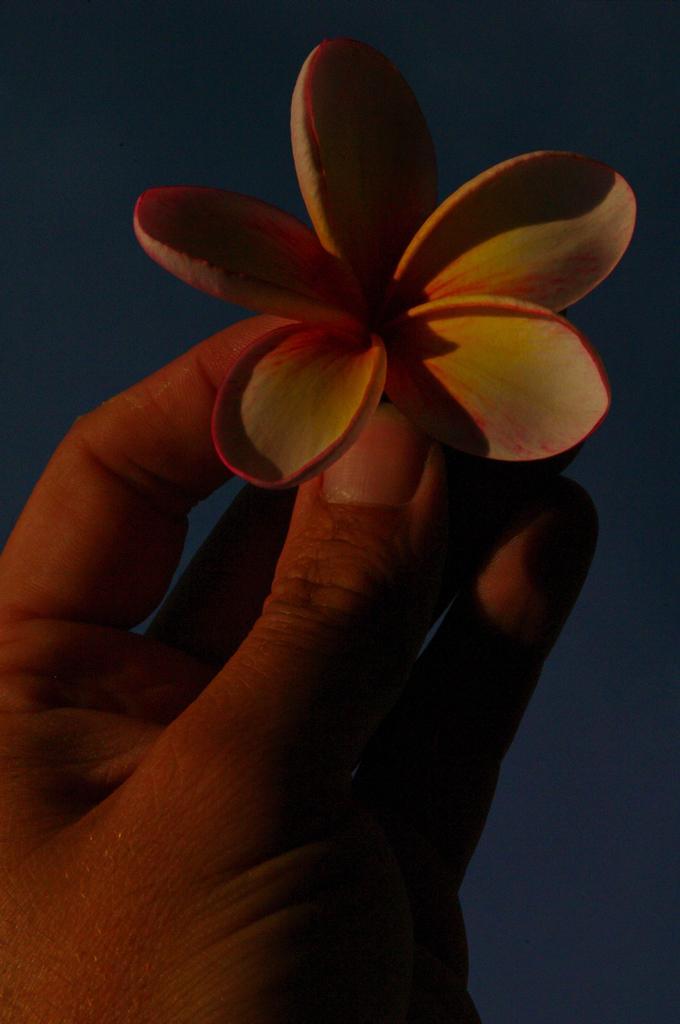How would you summarize this image in a sentence or two? In this picture we can see a person's hand and holding a flower. 